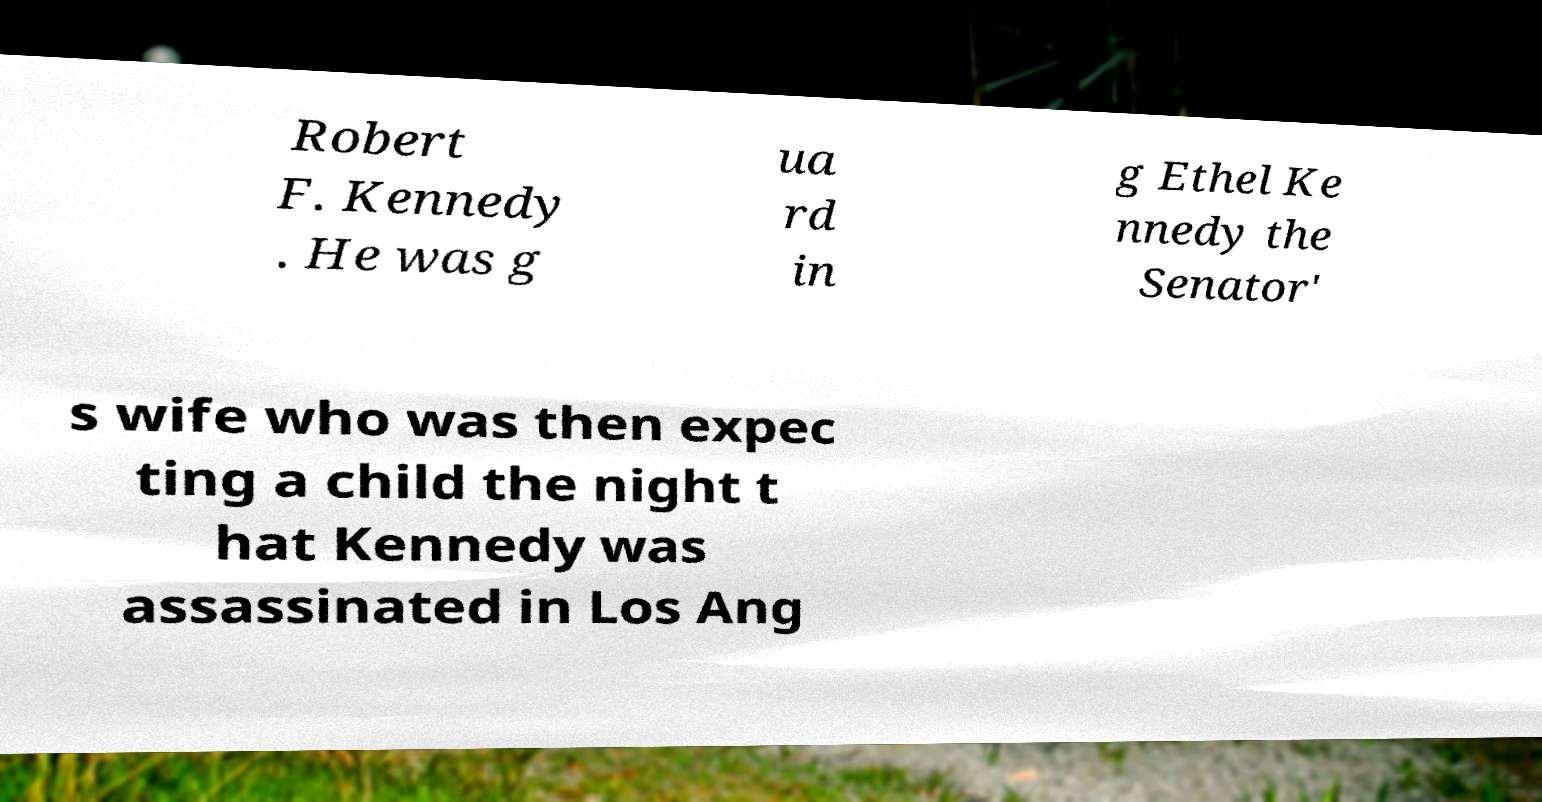Can you accurately transcribe the text from the provided image for me? Robert F. Kennedy . He was g ua rd in g Ethel Ke nnedy the Senator' s wife who was then expec ting a child the night t hat Kennedy was assassinated in Los Ang 